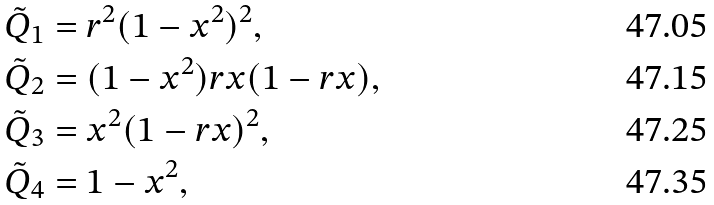Convert formula to latex. <formula><loc_0><loc_0><loc_500><loc_500>& \tilde { Q } _ { 1 } = r ^ { 2 } ( 1 - x ^ { 2 } ) ^ { 2 } , \\ & \tilde { Q } _ { 2 } = ( 1 - x ^ { 2 } ) r x ( 1 - r x ) , \\ & \tilde { Q } _ { 3 } = x ^ { 2 } ( 1 - r x ) ^ { 2 } , \\ & \tilde { Q } _ { 4 } = 1 - x ^ { 2 } ,</formula> 